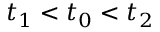<formula> <loc_0><loc_0><loc_500><loc_500>t _ { 1 } < t _ { 0 } < t _ { 2 }</formula> 